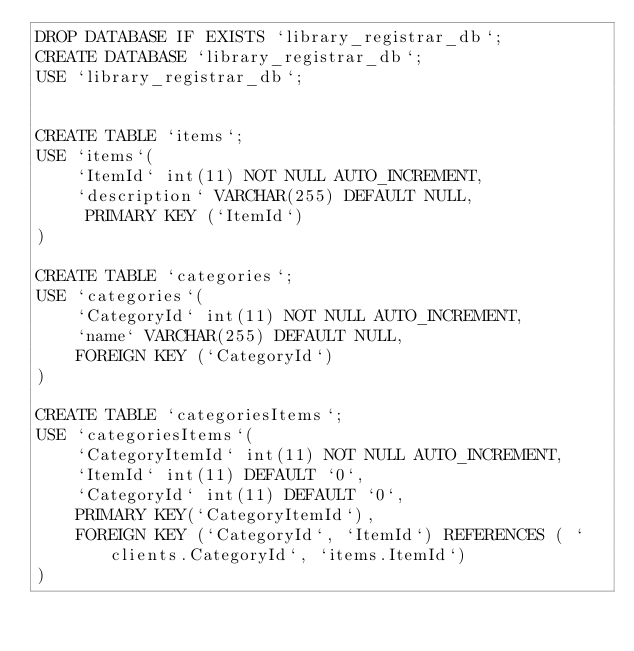<code> <loc_0><loc_0><loc_500><loc_500><_SQL_>DROP DATABASE IF EXISTS `library_registrar_db`;
CREATE DATABASE `library_registrar_db`;
USE `library_registrar_db`;


CREATE TABLE `items`;
USE `items`(
    `ItemId` int(11) NOT NULL AUTO_INCREMENT,
    `description` VARCHAR(255) DEFAULT NULL, 
     PRIMARY KEY (`ItemId`)
)

CREATE TABLE `categories`;
USE `categories`(
    `CategoryId` int(11) NOT NULL AUTO_INCREMENT, 
    `name` VARCHAR(255) DEFAULT NULL,
    FOREIGN KEY (`CategoryId`)
)

CREATE TABLE `categoriesItems`;
USE `categoriesItems`(
    `CategoryItemId` int(11) NOT NULL AUTO_INCREMENT,
    `ItemId` int(11) DEFAULT `0`,
    `CategoryId` int(11) DEFAULT `0`,
    PRIMARY KEY(`CategoryItemId`),
    FOREIGN KEY (`CategoryId`, `ItemId`) REFERENCES ( `clients.CategoryId`, `items.ItemId`)
)


</code> 